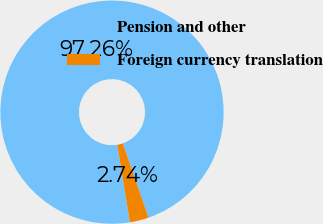Convert chart to OTSL. <chart><loc_0><loc_0><loc_500><loc_500><pie_chart><fcel>Pension and other<fcel>Foreign currency translation<nl><fcel>97.26%<fcel>2.74%<nl></chart> 